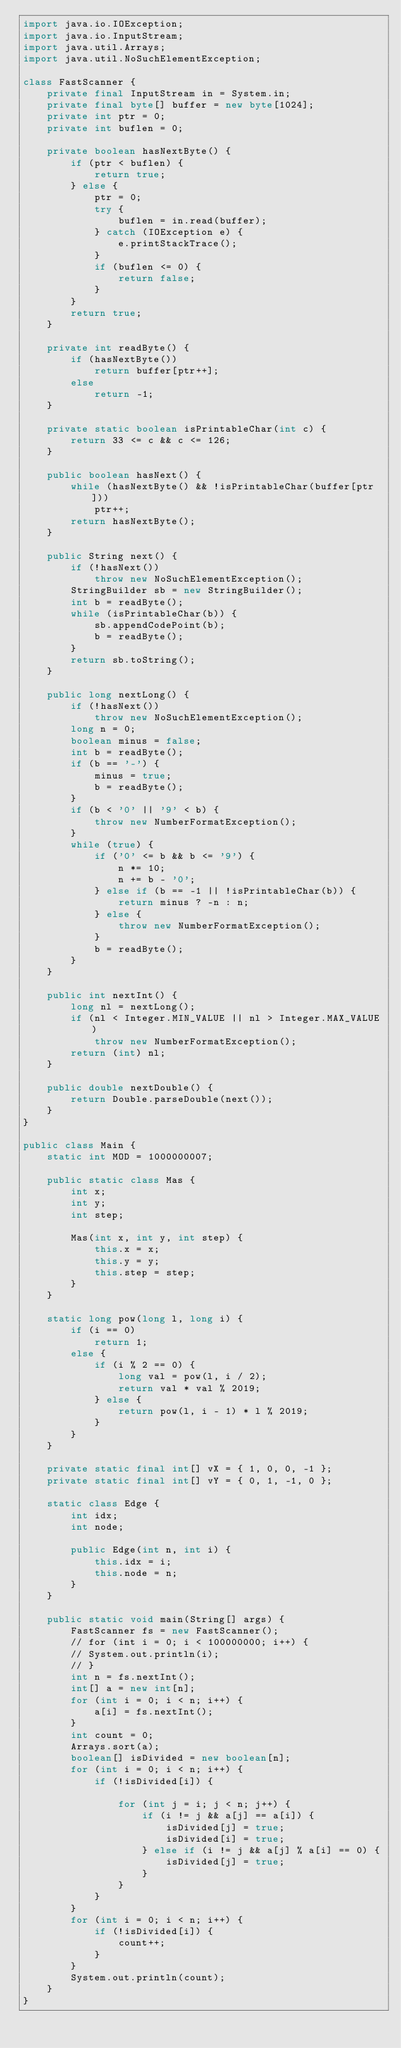Convert code to text. <code><loc_0><loc_0><loc_500><loc_500><_Java_>import java.io.IOException;
import java.io.InputStream;
import java.util.Arrays;
import java.util.NoSuchElementException;

class FastScanner {
    private final InputStream in = System.in;
    private final byte[] buffer = new byte[1024];
    private int ptr = 0;
    private int buflen = 0;

    private boolean hasNextByte() {
        if (ptr < buflen) {
            return true;
        } else {
            ptr = 0;
            try {
                buflen = in.read(buffer);
            } catch (IOException e) {
                e.printStackTrace();
            }
            if (buflen <= 0) {
                return false;
            }
        }
        return true;
    }

    private int readByte() {
        if (hasNextByte())
            return buffer[ptr++];
        else
            return -1;
    }

    private static boolean isPrintableChar(int c) {
        return 33 <= c && c <= 126;
    }

    public boolean hasNext() {
        while (hasNextByte() && !isPrintableChar(buffer[ptr]))
            ptr++;
        return hasNextByte();
    }

    public String next() {
        if (!hasNext())
            throw new NoSuchElementException();
        StringBuilder sb = new StringBuilder();
        int b = readByte();
        while (isPrintableChar(b)) {
            sb.appendCodePoint(b);
            b = readByte();
        }
        return sb.toString();
    }

    public long nextLong() {
        if (!hasNext())
            throw new NoSuchElementException();
        long n = 0;
        boolean minus = false;
        int b = readByte();
        if (b == '-') {
            minus = true;
            b = readByte();
        }
        if (b < '0' || '9' < b) {
            throw new NumberFormatException();
        }
        while (true) {
            if ('0' <= b && b <= '9') {
                n *= 10;
                n += b - '0';
            } else if (b == -1 || !isPrintableChar(b)) {
                return minus ? -n : n;
            } else {
                throw new NumberFormatException();
            }
            b = readByte();
        }
    }

    public int nextInt() {
        long nl = nextLong();
        if (nl < Integer.MIN_VALUE || nl > Integer.MAX_VALUE)
            throw new NumberFormatException();
        return (int) nl;
    }

    public double nextDouble() {
        return Double.parseDouble(next());
    }
}

public class Main {
    static int MOD = 1000000007;

    public static class Mas {
        int x;
        int y;
        int step;

        Mas(int x, int y, int step) {
            this.x = x;
            this.y = y;
            this.step = step;
        }
    }

    static long pow(long l, long i) {
        if (i == 0)
            return 1;
        else {
            if (i % 2 == 0) {
                long val = pow(l, i / 2);
                return val * val % 2019;
            } else {
                return pow(l, i - 1) * l % 2019;
            }
        }
    }

    private static final int[] vX = { 1, 0, 0, -1 };
    private static final int[] vY = { 0, 1, -1, 0 };

    static class Edge {
        int idx;
        int node;

        public Edge(int n, int i) {
            this.idx = i;
            this.node = n;
        }
    }

    public static void main(String[] args) {
        FastScanner fs = new FastScanner();
        // for (int i = 0; i < 100000000; i++) {
        // System.out.println(i);
        // }
        int n = fs.nextInt();
        int[] a = new int[n];
        for (int i = 0; i < n; i++) {
            a[i] = fs.nextInt();
        }
        int count = 0;
        Arrays.sort(a);
        boolean[] isDivided = new boolean[n];
        for (int i = 0; i < n; i++) {
            if (!isDivided[i]) {

                for (int j = i; j < n; j++) {
                    if (i != j && a[j] == a[i]) {
                        isDivided[j] = true;
                        isDivided[i] = true;
                    } else if (i != j && a[j] % a[i] == 0) {
                        isDivided[j] = true;
                    }
                }
            }
        }
        for (int i = 0; i < n; i++) {
            if (!isDivided[i]) {
                count++;
            }
        }
        System.out.println(count);
    }
}
</code> 